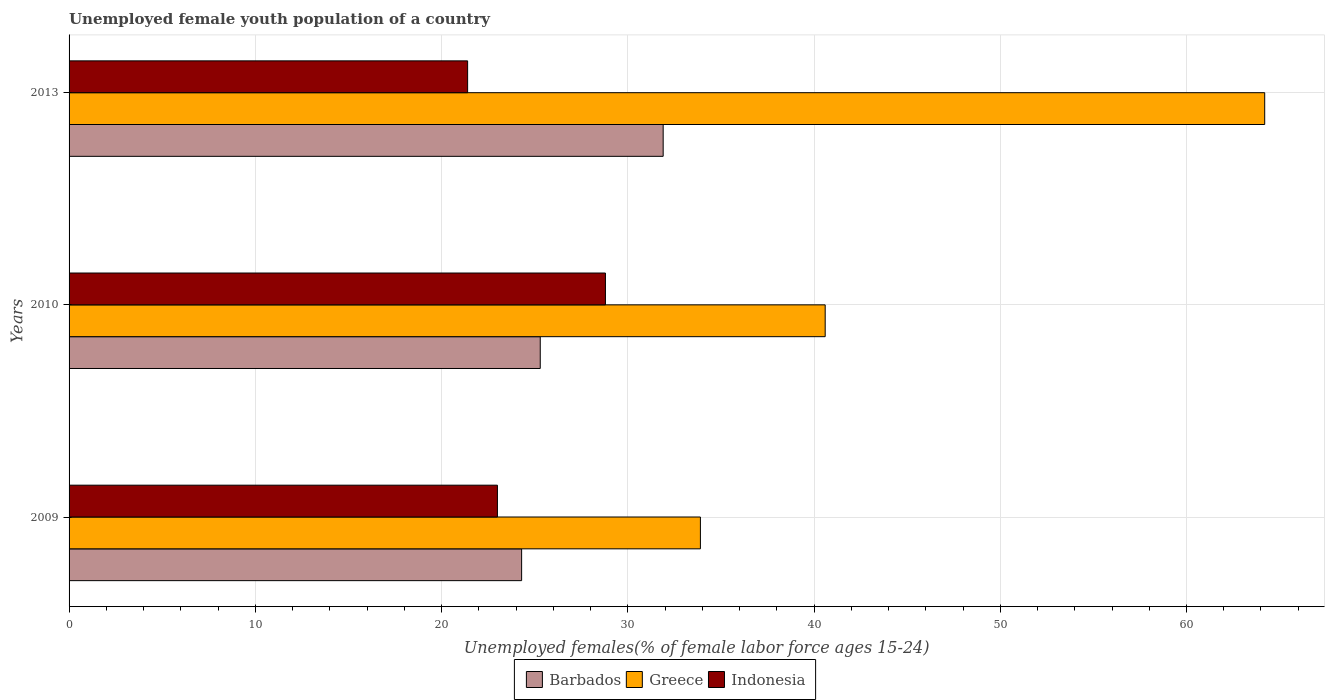How many different coloured bars are there?
Your answer should be very brief. 3. How many groups of bars are there?
Ensure brevity in your answer.  3. Are the number of bars per tick equal to the number of legend labels?
Give a very brief answer. Yes. How many bars are there on the 2nd tick from the top?
Your answer should be very brief. 3. How many bars are there on the 3rd tick from the bottom?
Provide a succinct answer. 3. What is the label of the 1st group of bars from the top?
Your answer should be compact. 2013. What is the percentage of unemployed female youth population in Barbados in 2010?
Give a very brief answer. 25.3. Across all years, what is the maximum percentage of unemployed female youth population in Greece?
Your answer should be compact. 64.2. Across all years, what is the minimum percentage of unemployed female youth population in Barbados?
Offer a very short reply. 24.3. In which year was the percentage of unemployed female youth population in Greece minimum?
Ensure brevity in your answer.  2009. What is the total percentage of unemployed female youth population in Barbados in the graph?
Your answer should be compact. 81.5. What is the difference between the percentage of unemployed female youth population in Greece in 2009 and that in 2010?
Provide a succinct answer. -6.7. What is the difference between the percentage of unemployed female youth population in Indonesia in 2009 and the percentage of unemployed female youth population in Greece in 2013?
Your answer should be compact. -41.2. What is the average percentage of unemployed female youth population in Indonesia per year?
Offer a very short reply. 24.4. In the year 2013, what is the difference between the percentage of unemployed female youth population in Greece and percentage of unemployed female youth population in Indonesia?
Give a very brief answer. 42.8. In how many years, is the percentage of unemployed female youth population in Indonesia greater than 58 %?
Make the answer very short. 0. What is the ratio of the percentage of unemployed female youth population in Greece in 2010 to that in 2013?
Provide a short and direct response. 0.63. What is the difference between the highest and the second highest percentage of unemployed female youth population in Barbados?
Provide a succinct answer. 6.6. What is the difference between the highest and the lowest percentage of unemployed female youth population in Greece?
Make the answer very short. 30.3. What does the 3rd bar from the top in 2013 represents?
Ensure brevity in your answer.  Barbados. What does the 3rd bar from the bottom in 2010 represents?
Provide a succinct answer. Indonesia. Is it the case that in every year, the sum of the percentage of unemployed female youth population in Barbados and percentage of unemployed female youth population in Indonesia is greater than the percentage of unemployed female youth population in Greece?
Your response must be concise. No. How many bars are there?
Offer a very short reply. 9. Are the values on the major ticks of X-axis written in scientific E-notation?
Keep it short and to the point. No. Does the graph contain any zero values?
Give a very brief answer. No. Where does the legend appear in the graph?
Offer a very short reply. Bottom center. How many legend labels are there?
Your answer should be compact. 3. What is the title of the graph?
Provide a short and direct response. Unemployed female youth population of a country. Does "Europe(all income levels)" appear as one of the legend labels in the graph?
Your response must be concise. No. What is the label or title of the X-axis?
Make the answer very short. Unemployed females(% of female labor force ages 15-24). What is the label or title of the Y-axis?
Make the answer very short. Years. What is the Unemployed females(% of female labor force ages 15-24) of Barbados in 2009?
Ensure brevity in your answer.  24.3. What is the Unemployed females(% of female labor force ages 15-24) of Greece in 2009?
Provide a succinct answer. 33.9. What is the Unemployed females(% of female labor force ages 15-24) in Barbados in 2010?
Your response must be concise. 25.3. What is the Unemployed females(% of female labor force ages 15-24) in Greece in 2010?
Offer a terse response. 40.6. What is the Unemployed females(% of female labor force ages 15-24) of Indonesia in 2010?
Offer a very short reply. 28.8. What is the Unemployed females(% of female labor force ages 15-24) in Barbados in 2013?
Ensure brevity in your answer.  31.9. What is the Unemployed females(% of female labor force ages 15-24) of Greece in 2013?
Keep it short and to the point. 64.2. What is the Unemployed females(% of female labor force ages 15-24) of Indonesia in 2013?
Make the answer very short. 21.4. Across all years, what is the maximum Unemployed females(% of female labor force ages 15-24) of Barbados?
Offer a very short reply. 31.9. Across all years, what is the maximum Unemployed females(% of female labor force ages 15-24) of Greece?
Your answer should be very brief. 64.2. Across all years, what is the maximum Unemployed females(% of female labor force ages 15-24) in Indonesia?
Offer a very short reply. 28.8. Across all years, what is the minimum Unemployed females(% of female labor force ages 15-24) of Barbados?
Provide a short and direct response. 24.3. Across all years, what is the minimum Unemployed females(% of female labor force ages 15-24) of Greece?
Provide a short and direct response. 33.9. Across all years, what is the minimum Unemployed females(% of female labor force ages 15-24) of Indonesia?
Ensure brevity in your answer.  21.4. What is the total Unemployed females(% of female labor force ages 15-24) in Barbados in the graph?
Offer a very short reply. 81.5. What is the total Unemployed females(% of female labor force ages 15-24) of Greece in the graph?
Your answer should be very brief. 138.7. What is the total Unemployed females(% of female labor force ages 15-24) of Indonesia in the graph?
Your answer should be very brief. 73.2. What is the difference between the Unemployed females(% of female labor force ages 15-24) in Greece in 2009 and that in 2010?
Offer a terse response. -6.7. What is the difference between the Unemployed females(% of female labor force ages 15-24) in Barbados in 2009 and that in 2013?
Provide a short and direct response. -7.6. What is the difference between the Unemployed females(% of female labor force ages 15-24) in Greece in 2009 and that in 2013?
Offer a terse response. -30.3. What is the difference between the Unemployed females(% of female labor force ages 15-24) in Indonesia in 2009 and that in 2013?
Offer a terse response. 1.6. What is the difference between the Unemployed females(% of female labor force ages 15-24) of Barbados in 2010 and that in 2013?
Offer a terse response. -6.6. What is the difference between the Unemployed females(% of female labor force ages 15-24) in Greece in 2010 and that in 2013?
Provide a succinct answer. -23.6. What is the difference between the Unemployed females(% of female labor force ages 15-24) in Barbados in 2009 and the Unemployed females(% of female labor force ages 15-24) in Greece in 2010?
Your response must be concise. -16.3. What is the difference between the Unemployed females(% of female labor force ages 15-24) of Barbados in 2009 and the Unemployed females(% of female labor force ages 15-24) of Indonesia in 2010?
Offer a very short reply. -4.5. What is the difference between the Unemployed females(% of female labor force ages 15-24) in Barbados in 2009 and the Unemployed females(% of female labor force ages 15-24) in Greece in 2013?
Provide a short and direct response. -39.9. What is the difference between the Unemployed females(% of female labor force ages 15-24) of Barbados in 2009 and the Unemployed females(% of female labor force ages 15-24) of Indonesia in 2013?
Provide a short and direct response. 2.9. What is the difference between the Unemployed females(% of female labor force ages 15-24) of Barbados in 2010 and the Unemployed females(% of female labor force ages 15-24) of Greece in 2013?
Give a very brief answer. -38.9. What is the difference between the Unemployed females(% of female labor force ages 15-24) of Barbados in 2010 and the Unemployed females(% of female labor force ages 15-24) of Indonesia in 2013?
Your response must be concise. 3.9. What is the difference between the Unemployed females(% of female labor force ages 15-24) of Greece in 2010 and the Unemployed females(% of female labor force ages 15-24) of Indonesia in 2013?
Provide a short and direct response. 19.2. What is the average Unemployed females(% of female labor force ages 15-24) of Barbados per year?
Your answer should be compact. 27.17. What is the average Unemployed females(% of female labor force ages 15-24) of Greece per year?
Make the answer very short. 46.23. What is the average Unemployed females(% of female labor force ages 15-24) of Indonesia per year?
Your answer should be compact. 24.4. In the year 2009, what is the difference between the Unemployed females(% of female labor force ages 15-24) in Greece and Unemployed females(% of female labor force ages 15-24) in Indonesia?
Ensure brevity in your answer.  10.9. In the year 2010, what is the difference between the Unemployed females(% of female labor force ages 15-24) of Barbados and Unemployed females(% of female labor force ages 15-24) of Greece?
Make the answer very short. -15.3. In the year 2013, what is the difference between the Unemployed females(% of female labor force ages 15-24) of Barbados and Unemployed females(% of female labor force ages 15-24) of Greece?
Give a very brief answer. -32.3. In the year 2013, what is the difference between the Unemployed females(% of female labor force ages 15-24) of Barbados and Unemployed females(% of female labor force ages 15-24) of Indonesia?
Give a very brief answer. 10.5. In the year 2013, what is the difference between the Unemployed females(% of female labor force ages 15-24) in Greece and Unemployed females(% of female labor force ages 15-24) in Indonesia?
Your answer should be compact. 42.8. What is the ratio of the Unemployed females(% of female labor force ages 15-24) of Barbados in 2009 to that in 2010?
Give a very brief answer. 0.96. What is the ratio of the Unemployed females(% of female labor force ages 15-24) in Greece in 2009 to that in 2010?
Keep it short and to the point. 0.83. What is the ratio of the Unemployed females(% of female labor force ages 15-24) in Indonesia in 2009 to that in 2010?
Your answer should be compact. 0.8. What is the ratio of the Unemployed females(% of female labor force ages 15-24) of Barbados in 2009 to that in 2013?
Provide a succinct answer. 0.76. What is the ratio of the Unemployed females(% of female labor force ages 15-24) of Greece in 2009 to that in 2013?
Offer a very short reply. 0.53. What is the ratio of the Unemployed females(% of female labor force ages 15-24) of Indonesia in 2009 to that in 2013?
Make the answer very short. 1.07. What is the ratio of the Unemployed females(% of female labor force ages 15-24) of Barbados in 2010 to that in 2013?
Make the answer very short. 0.79. What is the ratio of the Unemployed females(% of female labor force ages 15-24) in Greece in 2010 to that in 2013?
Provide a short and direct response. 0.63. What is the ratio of the Unemployed females(% of female labor force ages 15-24) in Indonesia in 2010 to that in 2013?
Offer a terse response. 1.35. What is the difference between the highest and the second highest Unemployed females(% of female labor force ages 15-24) in Greece?
Your answer should be compact. 23.6. What is the difference between the highest and the lowest Unemployed females(% of female labor force ages 15-24) of Barbados?
Offer a terse response. 7.6. What is the difference between the highest and the lowest Unemployed females(% of female labor force ages 15-24) in Greece?
Your answer should be very brief. 30.3. 